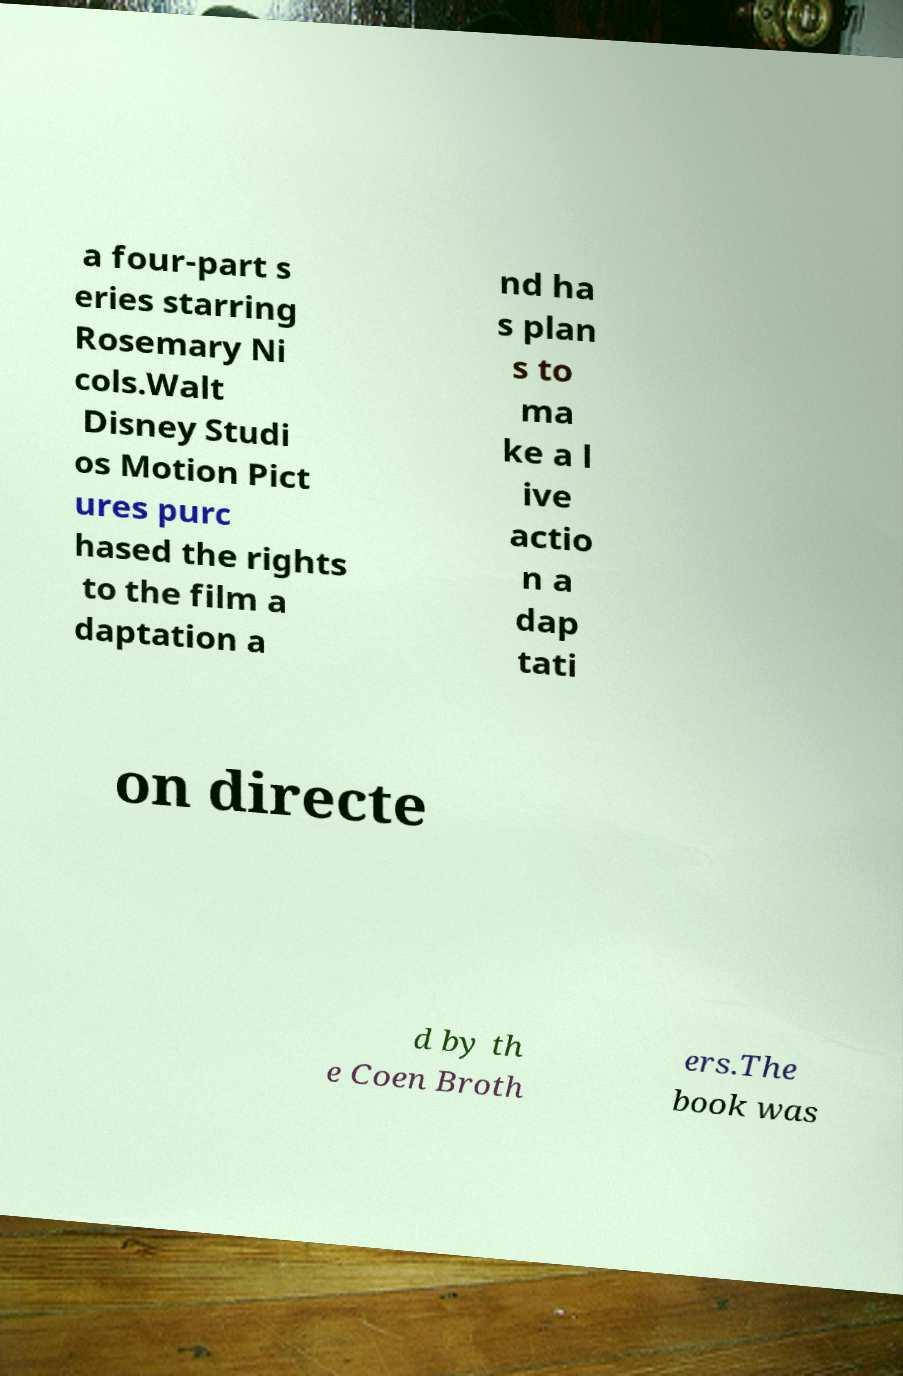Please identify and transcribe the text found in this image. a four-part s eries starring Rosemary Ni cols.Walt Disney Studi os Motion Pict ures purc hased the rights to the film a daptation a nd ha s plan s to ma ke a l ive actio n a dap tati on directe d by th e Coen Broth ers.The book was 